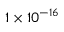<formula> <loc_0><loc_0><loc_500><loc_500>1 \times 1 0 ^ { - 1 6 }</formula> 